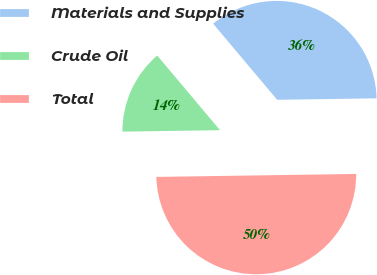<chart> <loc_0><loc_0><loc_500><loc_500><pie_chart><fcel>Materials and Supplies<fcel>Crude Oil<fcel>Total<nl><fcel>35.9%<fcel>14.1%<fcel>50.0%<nl></chart> 